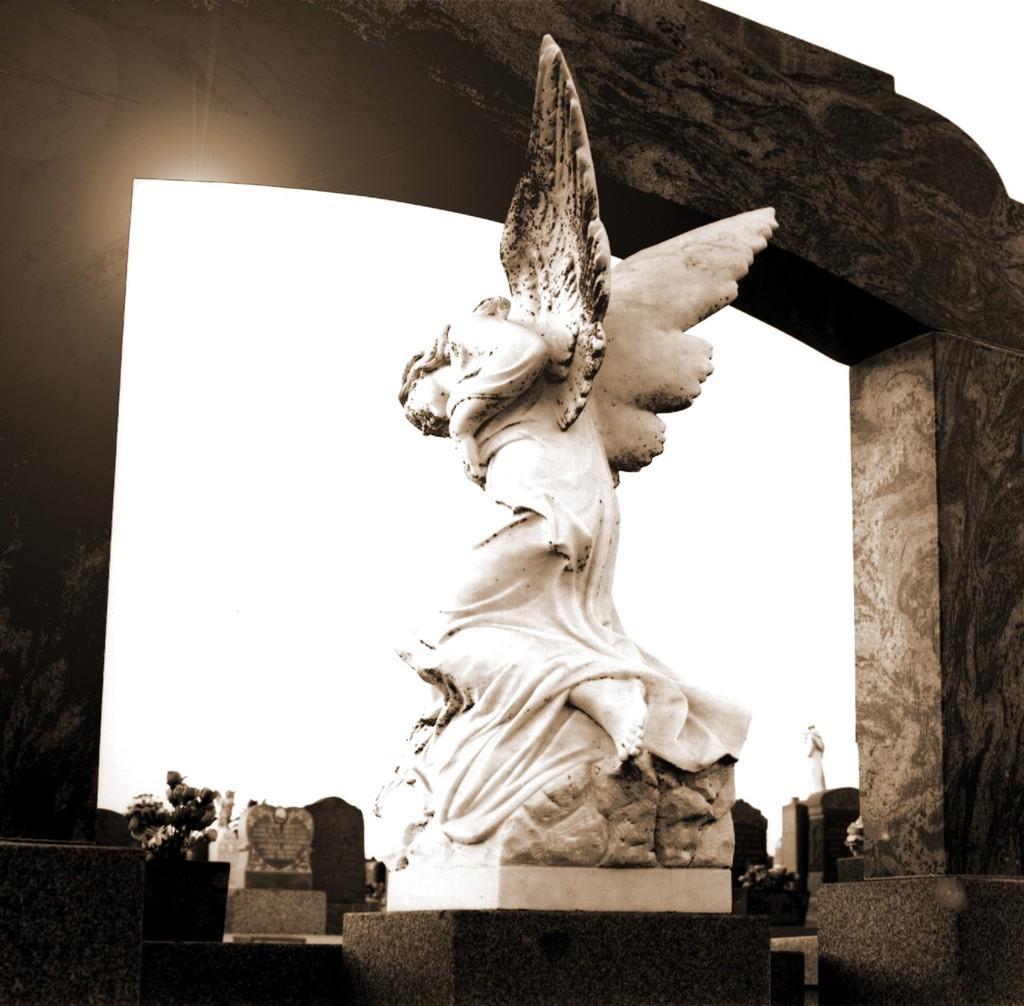Please provide a concise description of this image. As we can see in the image there is a statue, buildings and sky. 